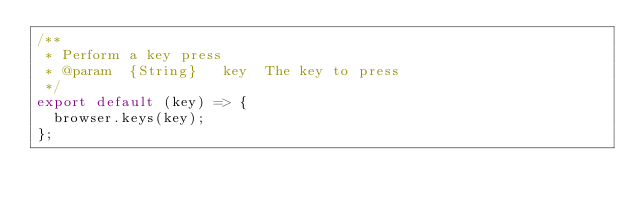<code> <loc_0><loc_0><loc_500><loc_500><_JavaScript_>/**
 * Perform a key press
 * @param  {String}   key  The key to press
 */
export default (key) => {
  browser.keys(key);
};
</code> 